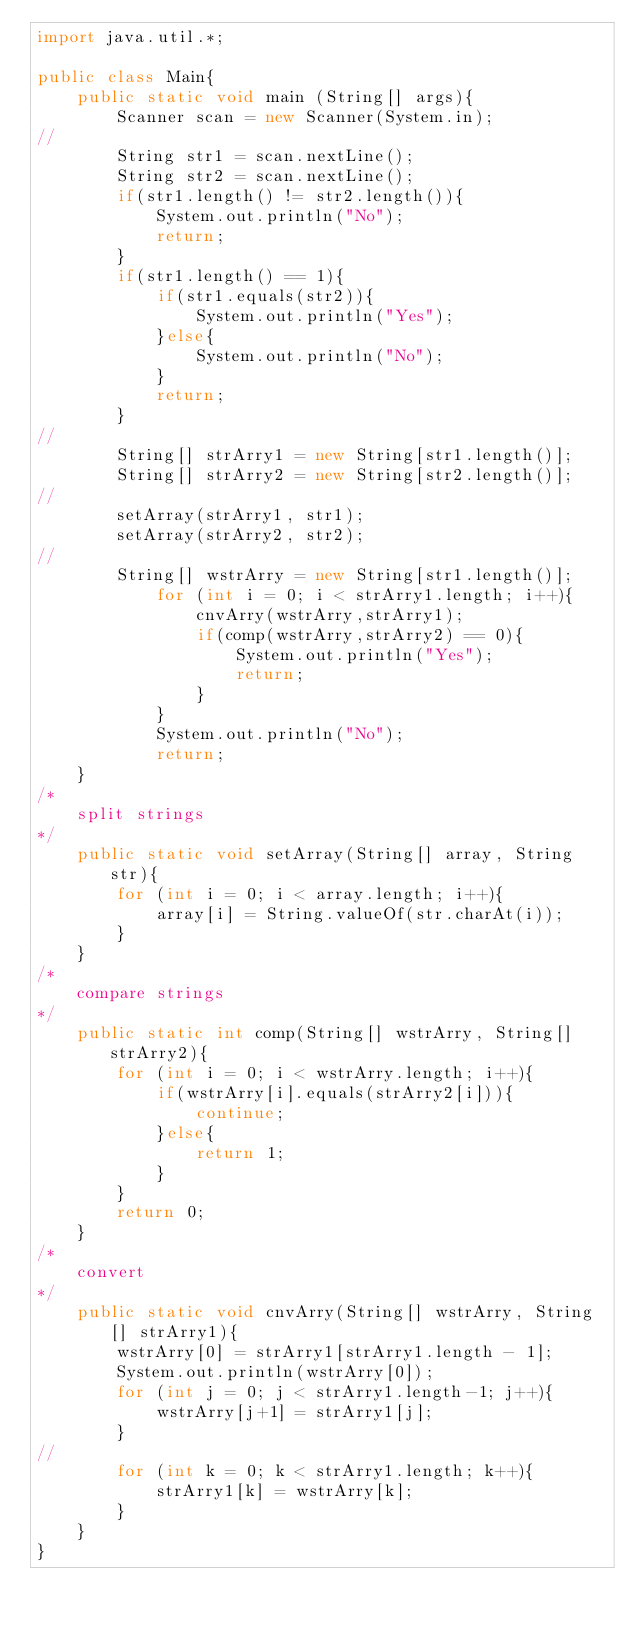Convert code to text. <code><loc_0><loc_0><loc_500><loc_500><_Java_>import java.util.*;

public class Main{
    public static void main (String[] args){
        Scanner scan = new Scanner(System.in);
//
        String str1 = scan.nextLine();
        String str2 = scan.nextLine();
        if(str1.length() != str2.length()){
            System.out.println("No");
            return;
        }
        if(str1.length() == 1){
            if(str1.equals(str2)){
                System.out.println("Yes");
            }else{
                System.out.println("No");
            }            
            return;
        }
//
        String[] strArry1 = new String[str1.length()];
        String[] strArry2 = new String[str2.length()];
//
        setArray(strArry1, str1);
        setArray(strArry2, str2);
//
        String[] wstrArry = new String[str1.length()];
            for (int i = 0; i < strArry1.length; i++){
                cnvArry(wstrArry,strArry1);
                if(comp(wstrArry,strArry2) == 0){
                    System.out.println("Yes");
                    return;
                }
            }            
            System.out.println("No");
            return;
    }
/*
    split strings
*/
    public static void setArray(String[] array, String str){
        for (int i = 0; i < array.length; i++){
            array[i] = String.valueOf(str.charAt(i));
        }
    }
/*
    compare strings
*/
    public static int comp(String[] wstrArry, String[] strArry2){
        for (int i = 0; i < wstrArry.length; i++){
            if(wstrArry[i].equals(strArry2[i])){
                continue;
            }else{                
                return 1;
            }
        }
        return 0;        
    }
/*
    convert
*/
    public static void cnvArry(String[] wstrArry, String[] strArry1){
        wstrArry[0] = strArry1[strArry1.length - 1];
        System.out.println(wstrArry[0]);
        for (int j = 0; j < strArry1.length-1; j++){
            wstrArry[j+1] = strArry1[j];
        }
//
        for (int k = 0; k < strArry1.length; k++){
            strArry1[k] = wstrArry[k];
        }
    }
}

</code> 